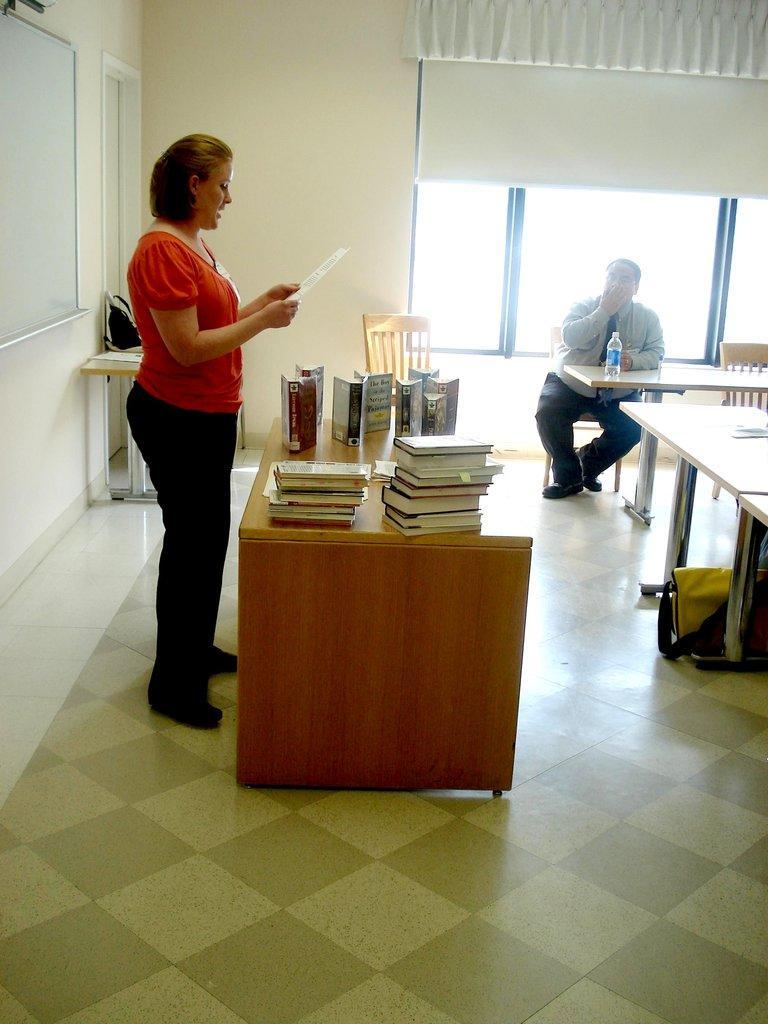Could you give a brief overview of what you see in this image? In this picture we can see one woman standing in front of a table and reading something and on the table we can see books. Here we can see tables and chairs. Here one man is sitting on a chair and there is a bottle on the table. This is a floor. this is a board. This is a wall and it's a window. 